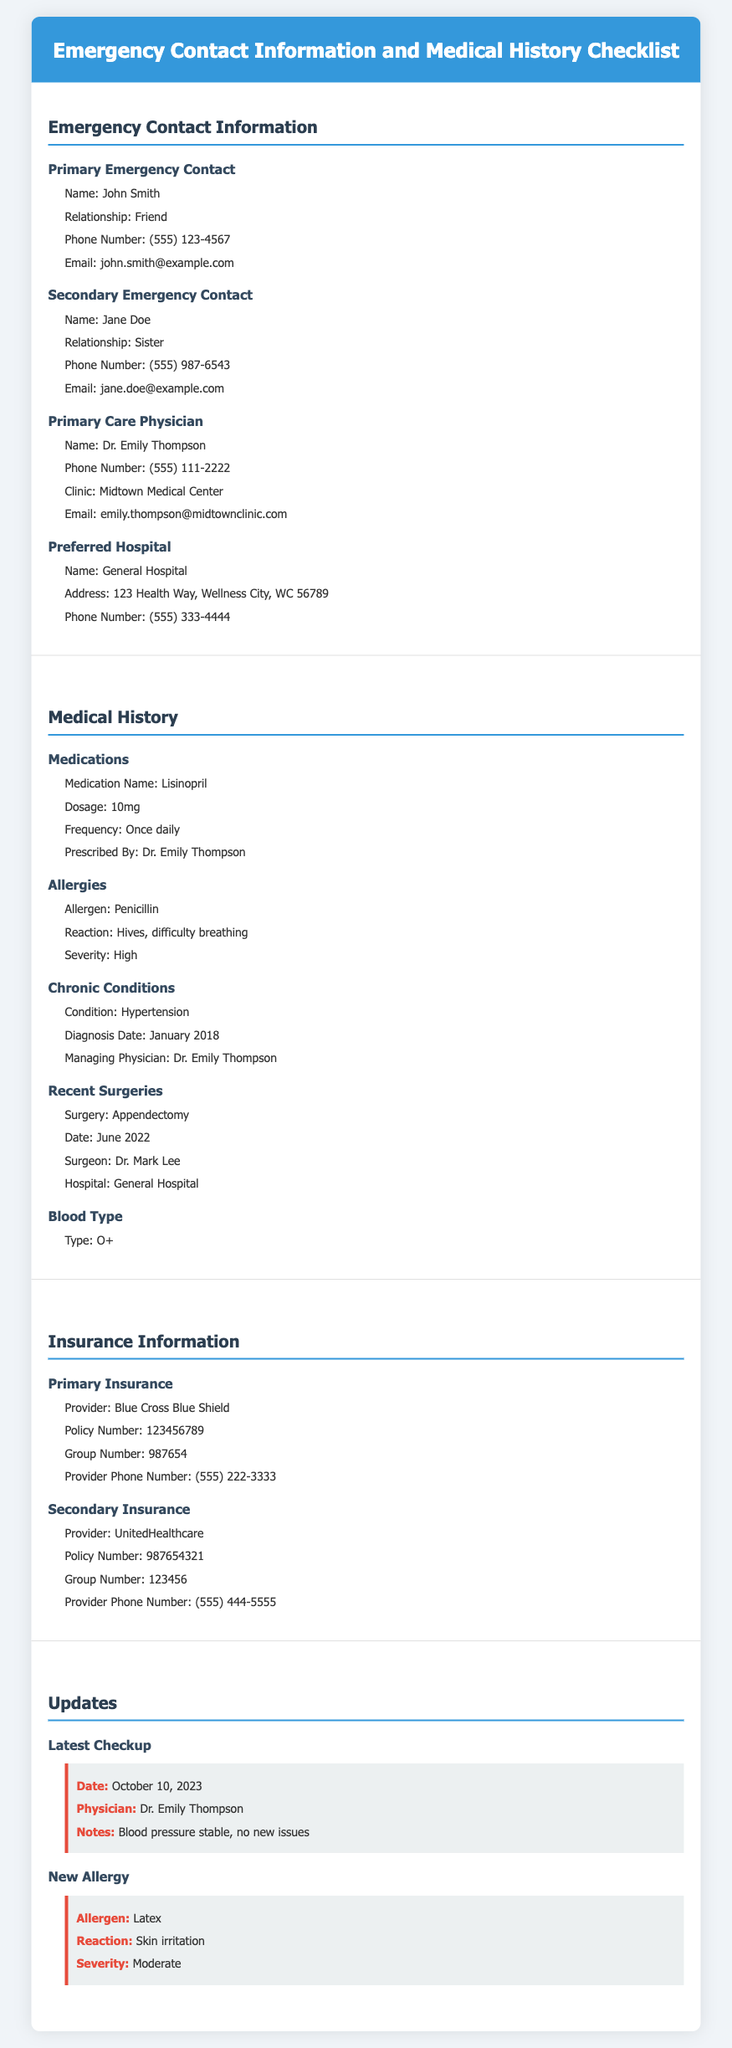What is the name of the primary emergency contact? The name of the primary emergency contact is listed in the Emergency Contact Information section of the document.
Answer: John Smith What is the relationship of the secondary emergency contact? The relationship of the secondary emergency contact can be found in the Emergency Contact Information section.
Answer: Sister What is the phone number of the preferred hospital? The preferred hospital's phone number is specified in the Emergency Contact Information section.
Answer: (555) 333-4444 What medication is prescribed for hypertension? The medication prescribed for hypertension is mentioned in the Medical History section.
Answer: Lisinopril When was the last checkup conducted? The date of the latest checkup is provided in the Updates section of the document.
Answer: October 10, 2023 What is the reaction to the new allergy? The reaction to the new allergy is described in the Updates section.
Answer: Skin irritation Who is the managing physician for chronic conditions? The managing physician for chronic conditions is listed in the Medical History section.
Answer: Dr. Emily Thompson What is the blood type mentioned in the document? The blood type is specified in the Medical History section.
Answer: O+ What is the provider name for the secondary insurance? The provider name for the secondary insurance is found in the Insurance Information section.
Answer: UnitedHealthcare 